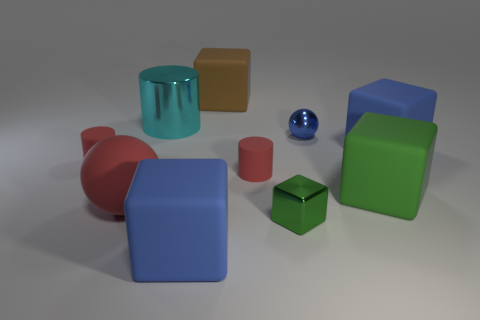Subtract 1 blocks. How many blocks are left? 4 Subtract all small green metal blocks. How many blocks are left? 4 Subtract all brown blocks. How many blocks are left? 4 Subtract all purple cubes. Subtract all cyan balls. How many cubes are left? 5 Subtract all cylinders. How many objects are left? 7 Subtract 1 red spheres. How many objects are left? 9 Subtract all large rubber objects. Subtract all large gray matte cubes. How many objects are left? 5 Add 3 brown things. How many brown things are left? 4 Add 4 cyan things. How many cyan things exist? 5 